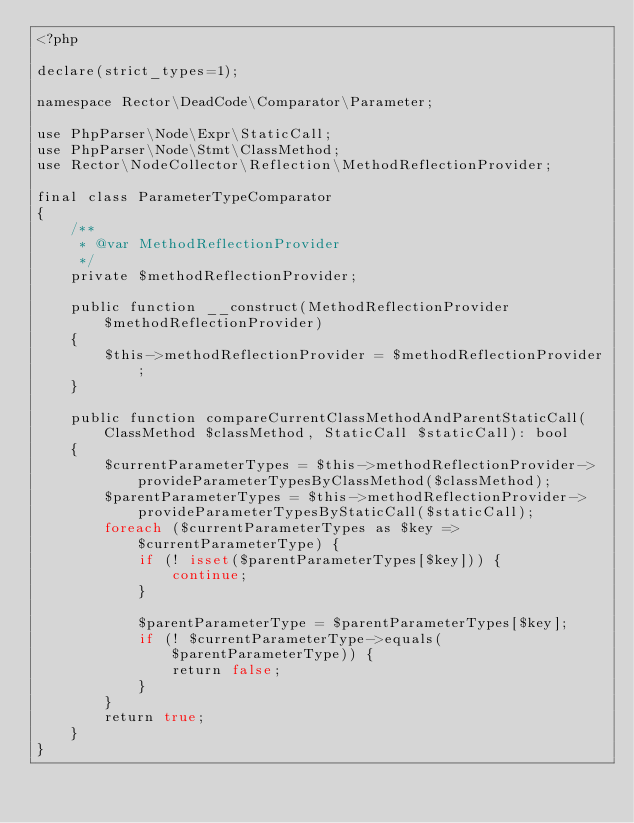Convert code to text. <code><loc_0><loc_0><loc_500><loc_500><_PHP_><?php

declare(strict_types=1);

namespace Rector\DeadCode\Comparator\Parameter;

use PhpParser\Node\Expr\StaticCall;
use PhpParser\Node\Stmt\ClassMethod;
use Rector\NodeCollector\Reflection\MethodReflectionProvider;

final class ParameterTypeComparator
{
    /**
     * @var MethodReflectionProvider
     */
    private $methodReflectionProvider;

    public function __construct(MethodReflectionProvider $methodReflectionProvider)
    {
        $this->methodReflectionProvider = $methodReflectionProvider;
    }

    public function compareCurrentClassMethodAndParentStaticCall(ClassMethod $classMethod, StaticCall $staticCall): bool
    {
        $currentParameterTypes = $this->methodReflectionProvider->provideParameterTypesByClassMethod($classMethod);
        $parentParameterTypes = $this->methodReflectionProvider->provideParameterTypesByStaticCall($staticCall);
        foreach ($currentParameterTypes as $key => $currentParameterType) {
            if (! isset($parentParameterTypes[$key])) {
                continue;
            }

            $parentParameterType = $parentParameterTypes[$key];
            if (! $currentParameterType->equals($parentParameterType)) {
                return false;
            }
        }
        return true;
    }
}
</code> 